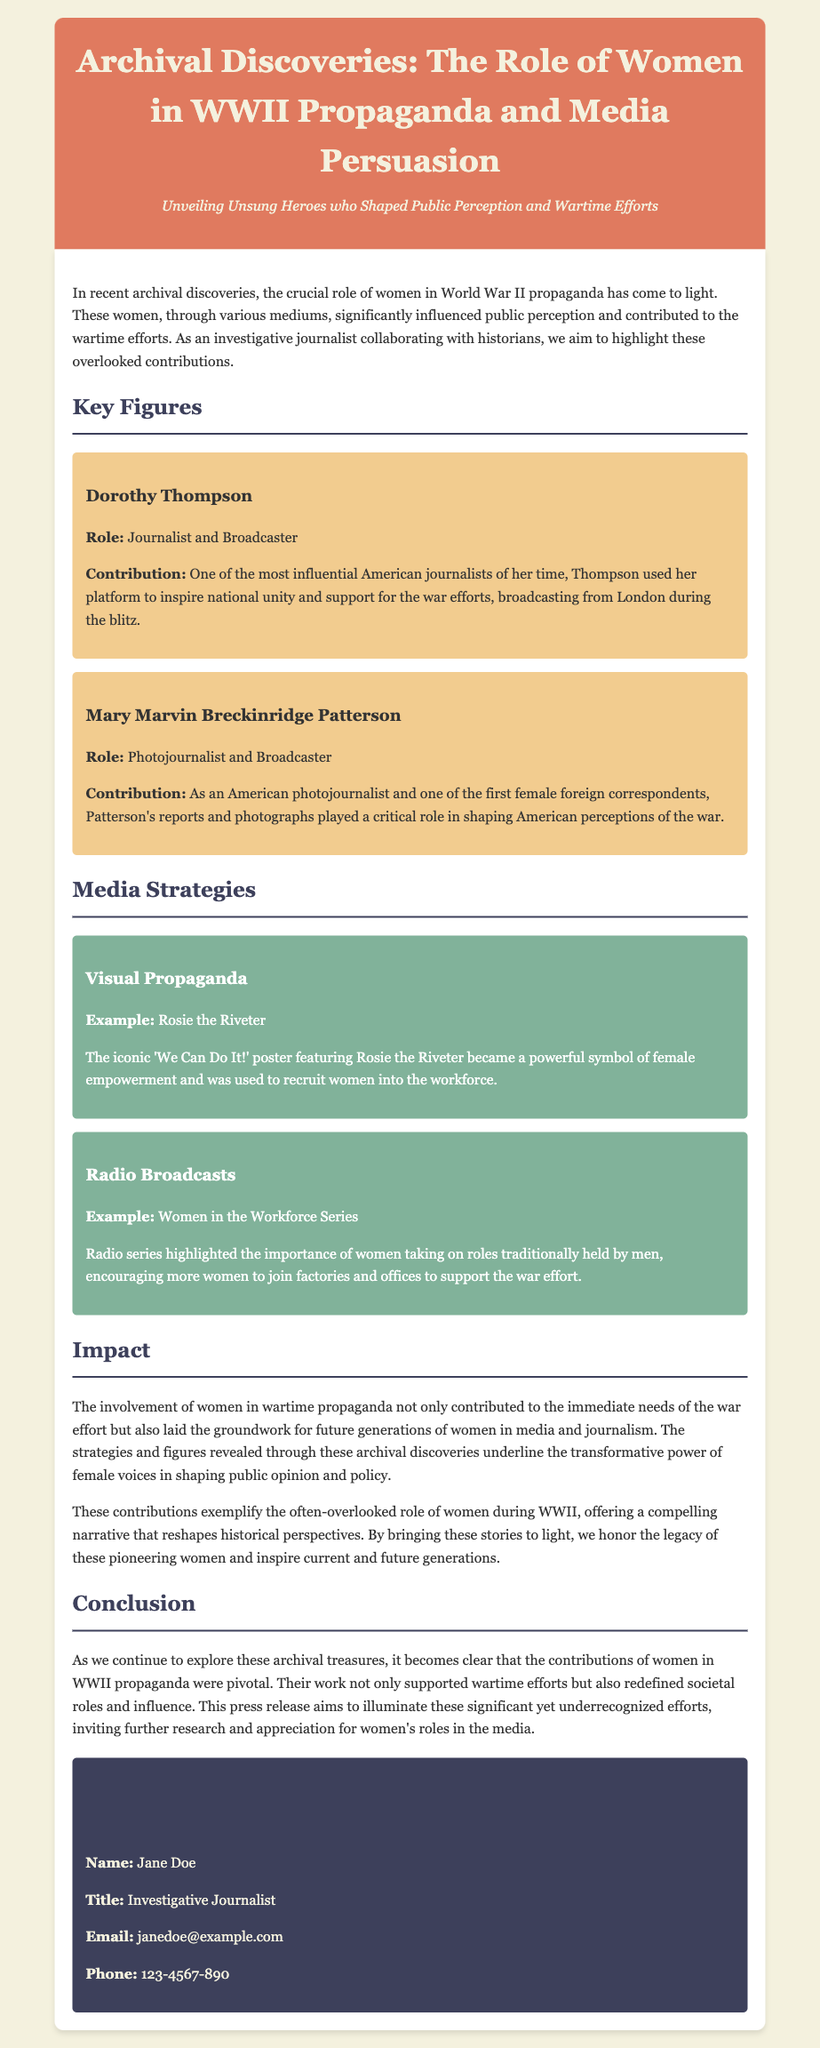what is the title of the press release? The title of the press release is found at the top of the document.
Answer: Archival Discoveries: The Role of Women in WWII Propaganda and Media Persuasion who is one of the key figures mentioned in the document? The document lists key figures who played significant roles, specifically notable individuals involved in WWII propaganda.
Answer: Dorothy Thompson what role did Mary Marvin Breckinridge Patterson have? Her role is described in relation to her contributions during WWII in the document.
Answer: Photojournalist and Broadcaster what example of visual propaganda is provided? The document mentions a specific example of visual propaganda that became iconic during that era.
Answer: Rosie the Riveter what is highlighted in the "Impact" section? The "Impact" section summarizes the contributions of women as described earlier in the document.
Answer: Pivotal contributions to the war effort who is the contact person for further inquiries? The contact information section provides details of who to reach out to regarding the press release.
Answer: Jane Doe what media strategy is discussed in the document? The document outlines specific strategies used by women in media during WWII, highlighting their innovative approaches.
Answer: Radio Broadcasts what was the purpose of the press release? The document explains the intention behind its release in the conclusion section.
Answer: To illuminate significant yet underrecognized efforts 